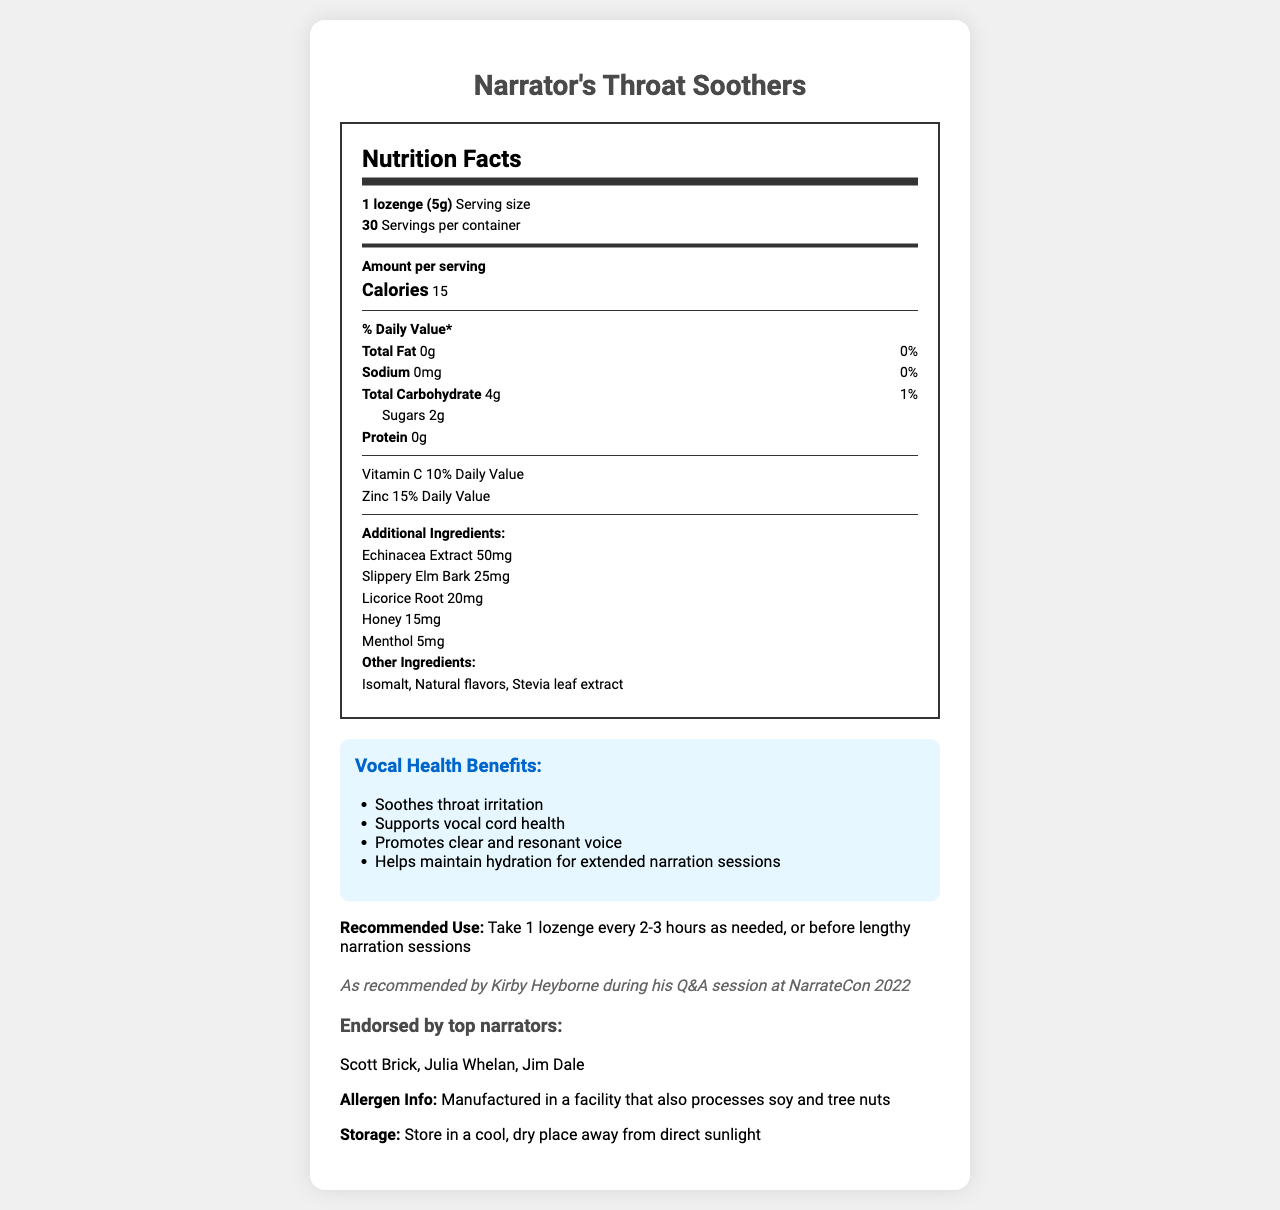which product is described in the document? The document title and several sections consistently refer to "Narrator's Throat Soothers" as the product.
Answer: Narrator's Throat Soothers how many calories are there per serving? The document lists "Calories" as 15 in the "Amount per serving" section.
Answer: 15 what is the recommended use for the lozenges? The "Recommended Use" section provides this information.
Answer: Take 1 lozenge every 2-3 hours as needed, or before lengthy narration sessions how many servings are there per container? The document states "30 Servings per container."
Answer: 30 how much menthol is in each lozenge? Under the "Additional Ingredients" section, the document specifies that each lozenge contains 5mg of menthol.
Answer: 5mg which key ingredient is found at the highest concentration in the lozenges? A. Echinacea Extract B. Slippery Elm Bark C. Licorice Root D. Honey Echinacea Extract is 50mg, which is higher than the other ingredients listed (Slippery Elm Bark 25mg, Licorice Root 20mg, Honey 15mg).
Answer: A. Echinacea Extract who endorsed the Narrator's Throat Soothers? A. Scott Brick B. Julia Whelan C. Jim Dale D. All of the above The "Endorsed by top narrators" section lists Scott Brick, Julia Whelan, and Jim Dale, indicating that all of them endorsed the product.
Answer: D. All of the above is the product free from fat and sodium? The document lists "Total Fat" as 0g and "Sodium" as 0mg, indicating it is free from both.
Answer: Yes what is the primary purpose of this product? The "Vocal Health Benefits" section lists benefits including soothing throat irritation and supporting vocal cord health.
Answer: To soothe throat irritation and support vocal health how much Vitamin C is in each serving? The "Vitamin C" section states that each serving provides 10% of the Daily Value.
Answer: 10% Daily Value in which genres is this product commonly used? The document mentions that the product is used in these audiobook genres.
Answer: Mystery, Young Adult, Non-fiction is the product manufactured in a facility free from allergen risks? The "Allergen Info" section states the product is manufactured in a facility that also processes soy and tree nuts.
Answer: No what's the main idea of this document? The document includes a nutrition facts label, detailed ingredient list, vocal health benefits, usage instructions, endorsements, and allergen and storage information, all centered around the lozenges and their benefits for narrators.
Answer: The document provides detailed nutritional information, usage recommendations, health benefits, and endorsements for Narrator's Throat Soothers lozenges, a product aimed at supporting vocal health. are there any artificial sweeteners listed in the ingredients? The document does not specify whether "Isomalt" and "Stevia leaf extract" are natural or artificial sweeteners explicitly; thus, it's insufficient to determine if they are "artificial" based on the presented information.
Answer: Not enough information 